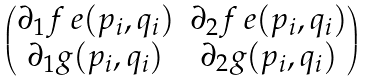<formula> <loc_0><loc_0><loc_500><loc_500>\begin{pmatrix} \partial _ { 1 } f _ { \ } e ( p _ { i } , q _ { i } ) & \partial _ { 2 } f _ { \ } e ( p _ { i } , q _ { i } ) \\ \partial _ { 1 } g ( p _ { i } , q _ { i } ) & \partial _ { 2 } g ( p _ { i } , q _ { i } ) \end{pmatrix}</formula> 